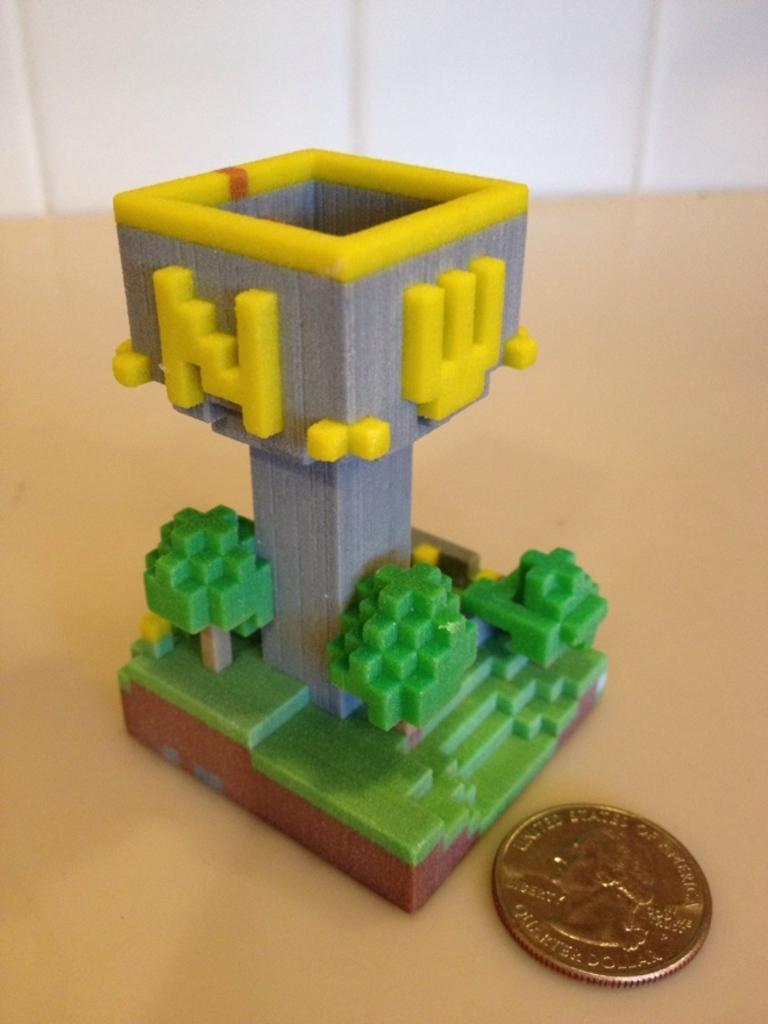Please provide a concise description of this image. In this image there is a Lego toy, beside that toy there is a coin. 